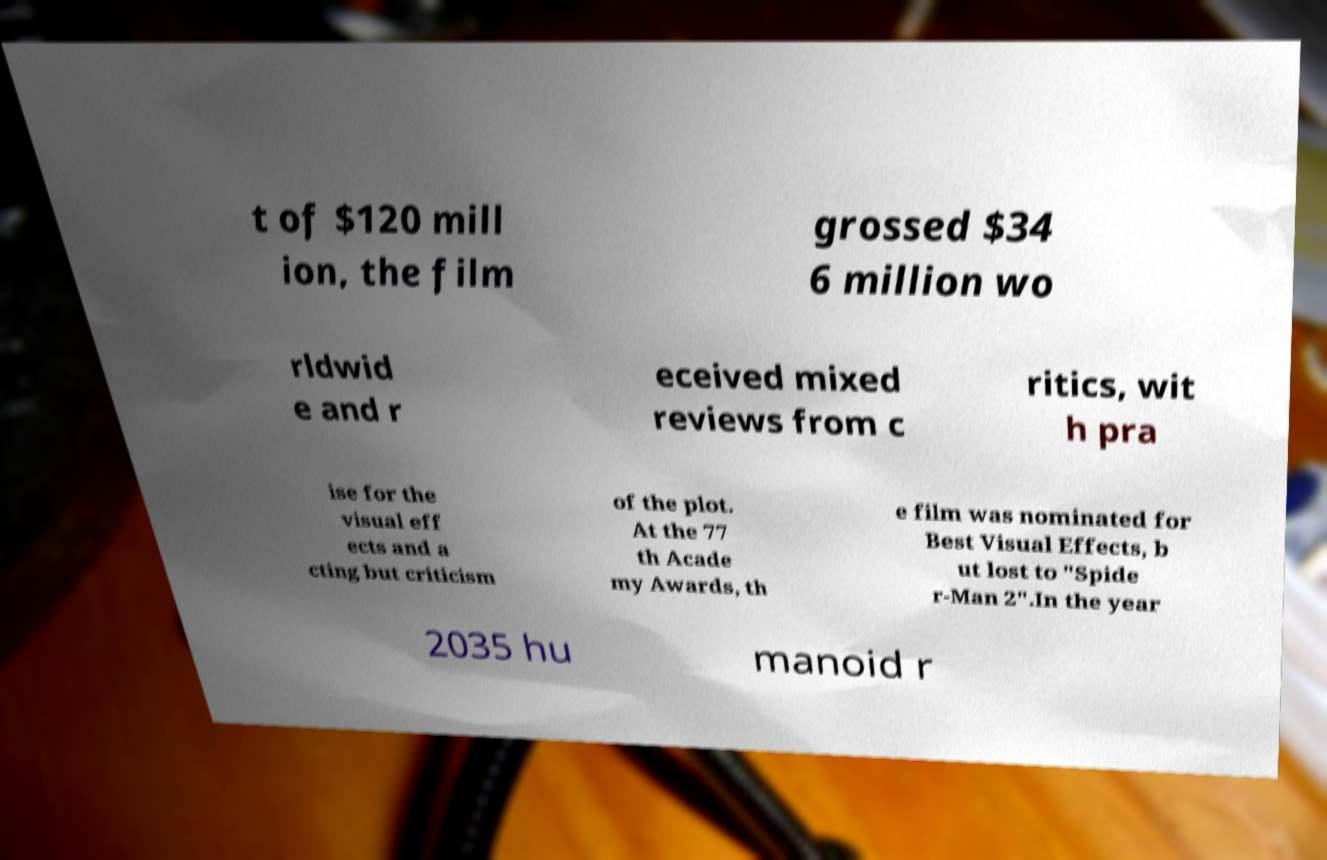What messages or text are displayed in this image? I need them in a readable, typed format. t of $120 mill ion, the film grossed $34 6 million wo rldwid e and r eceived mixed reviews from c ritics, wit h pra ise for the visual eff ects and a cting but criticism of the plot. At the 77 th Acade my Awards, th e film was nominated for Best Visual Effects, b ut lost to "Spide r-Man 2".In the year 2035 hu manoid r 